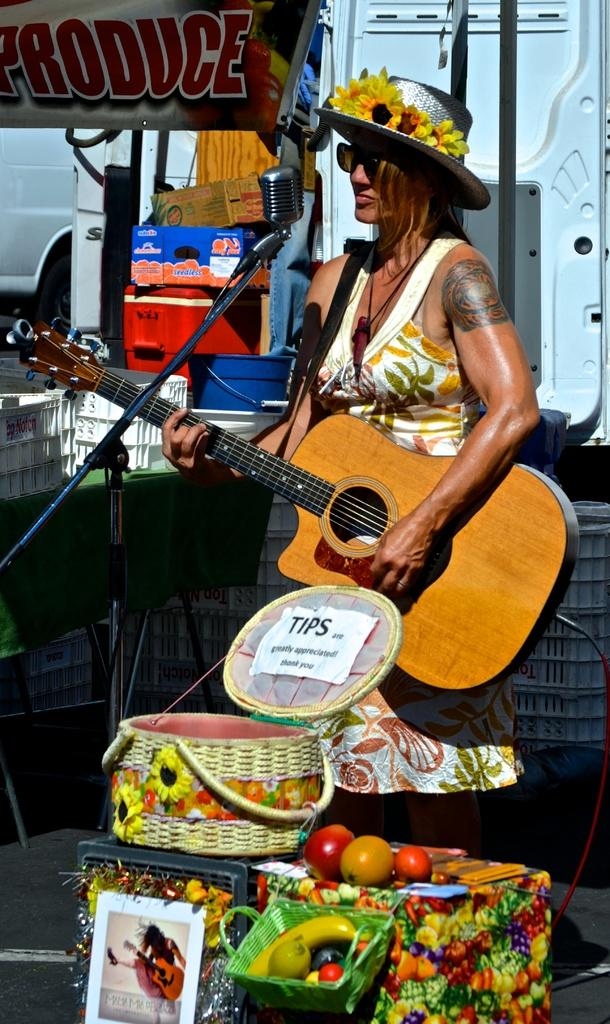Who is the main subject in the image? There is a woman in the image. What is the woman holding in the image? The woman is holding a guitar. What else can be seen in the image besides the woman and the guitar? There are baskets in the image. What are the baskets filled with? The baskets are filled with fruits. Can you see any ocean waves in the image? No, there is no ocean or ocean waves present in the image. Are there any cobwebs visible in the image? No, there are no cobwebs visible in the image. 